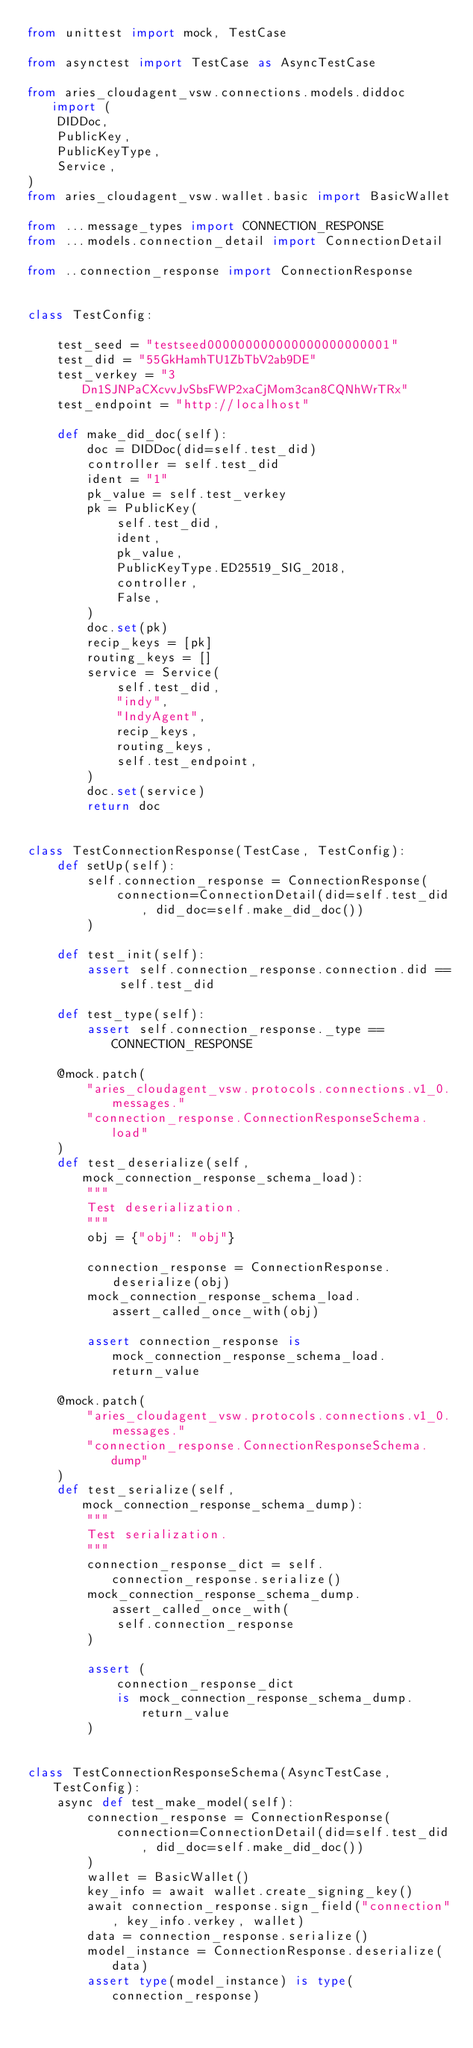Convert code to text. <code><loc_0><loc_0><loc_500><loc_500><_Python_>from unittest import mock, TestCase

from asynctest import TestCase as AsyncTestCase

from aries_cloudagent_vsw.connections.models.diddoc import (
    DIDDoc,
    PublicKey,
    PublicKeyType,
    Service,
)
from aries_cloudagent_vsw.wallet.basic import BasicWallet

from ...message_types import CONNECTION_RESPONSE
from ...models.connection_detail import ConnectionDetail

from ..connection_response import ConnectionResponse


class TestConfig:

    test_seed = "testseed000000000000000000000001"
    test_did = "55GkHamhTU1ZbTbV2ab9DE"
    test_verkey = "3Dn1SJNPaCXcvvJvSbsFWP2xaCjMom3can8CQNhWrTRx"
    test_endpoint = "http://localhost"

    def make_did_doc(self):
        doc = DIDDoc(did=self.test_did)
        controller = self.test_did
        ident = "1"
        pk_value = self.test_verkey
        pk = PublicKey(
            self.test_did,
            ident,
            pk_value,
            PublicKeyType.ED25519_SIG_2018,
            controller,
            False,
        )
        doc.set(pk)
        recip_keys = [pk]
        routing_keys = []
        service = Service(
            self.test_did,
            "indy",
            "IndyAgent",
            recip_keys,
            routing_keys,
            self.test_endpoint,
        )
        doc.set(service)
        return doc


class TestConnectionResponse(TestCase, TestConfig):
    def setUp(self):
        self.connection_response = ConnectionResponse(
            connection=ConnectionDetail(did=self.test_did, did_doc=self.make_did_doc())
        )

    def test_init(self):
        assert self.connection_response.connection.did == self.test_did

    def test_type(self):
        assert self.connection_response._type == CONNECTION_RESPONSE

    @mock.patch(
        "aries_cloudagent_vsw.protocols.connections.v1_0.messages."
        "connection_response.ConnectionResponseSchema.load"
    )
    def test_deserialize(self, mock_connection_response_schema_load):
        """
        Test deserialization.
        """
        obj = {"obj": "obj"}

        connection_response = ConnectionResponse.deserialize(obj)
        mock_connection_response_schema_load.assert_called_once_with(obj)

        assert connection_response is mock_connection_response_schema_load.return_value

    @mock.patch(
        "aries_cloudagent_vsw.protocols.connections.v1_0.messages."
        "connection_response.ConnectionResponseSchema.dump"
    )
    def test_serialize(self, mock_connection_response_schema_dump):
        """
        Test serialization.
        """
        connection_response_dict = self.connection_response.serialize()
        mock_connection_response_schema_dump.assert_called_once_with(
            self.connection_response
        )

        assert (
            connection_response_dict
            is mock_connection_response_schema_dump.return_value
        )


class TestConnectionResponseSchema(AsyncTestCase, TestConfig):
    async def test_make_model(self):
        connection_response = ConnectionResponse(
            connection=ConnectionDetail(did=self.test_did, did_doc=self.make_did_doc())
        )
        wallet = BasicWallet()
        key_info = await wallet.create_signing_key()
        await connection_response.sign_field("connection", key_info.verkey, wallet)
        data = connection_response.serialize()
        model_instance = ConnectionResponse.deserialize(data)
        assert type(model_instance) is type(connection_response)
</code> 